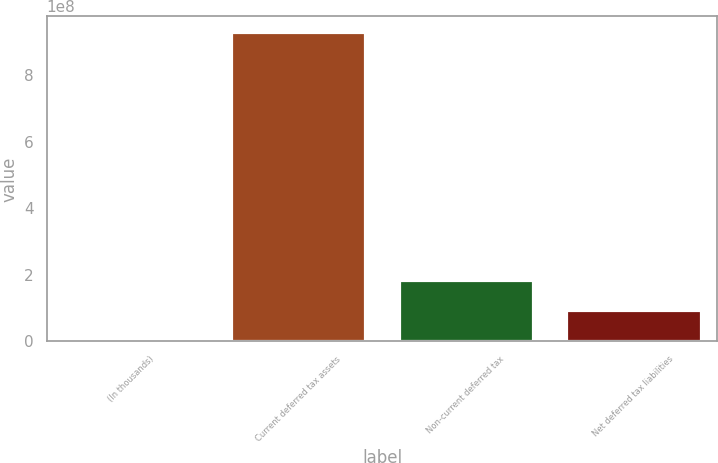Convert chart. <chart><loc_0><loc_0><loc_500><loc_500><bar_chart><fcel>(In thousands)<fcel>Current deferred tax assets<fcel>Non-current deferred tax<fcel>Net deferred tax liabilities<nl><fcel>2005<fcel>9.30329e+08<fcel>1.86067e+08<fcel>9.30347e+07<nl></chart> 